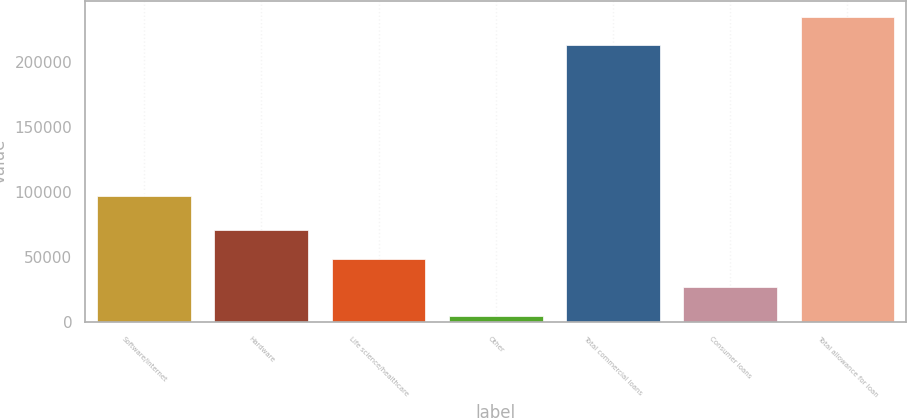Convert chart to OTSL. <chart><loc_0><loc_0><loc_500><loc_500><bar_chart><fcel>Software/internet<fcel>Hardware<fcel>Life science/healthcare<fcel>Other<fcel>Total commercial loans<fcel>Consumer loans<fcel>Total allowance for loan<nl><fcel>97388<fcel>70947.4<fcel>48887.6<fcel>4768<fcel>213182<fcel>26827.8<fcel>235242<nl></chart> 